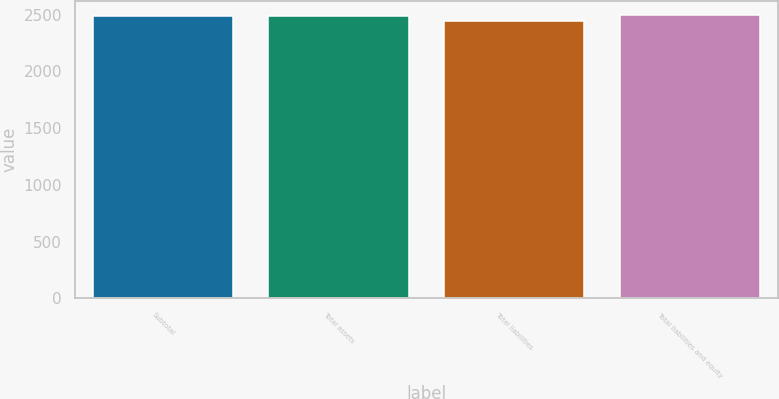Convert chart to OTSL. <chart><loc_0><loc_0><loc_500><loc_500><bar_chart><fcel>Subtotal<fcel>Total assets<fcel>Total liabilities<fcel>Total liabilities and equity<nl><fcel>2486<fcel>2490.3<fcel>2443<fcel>2494.6<nl></chart> 